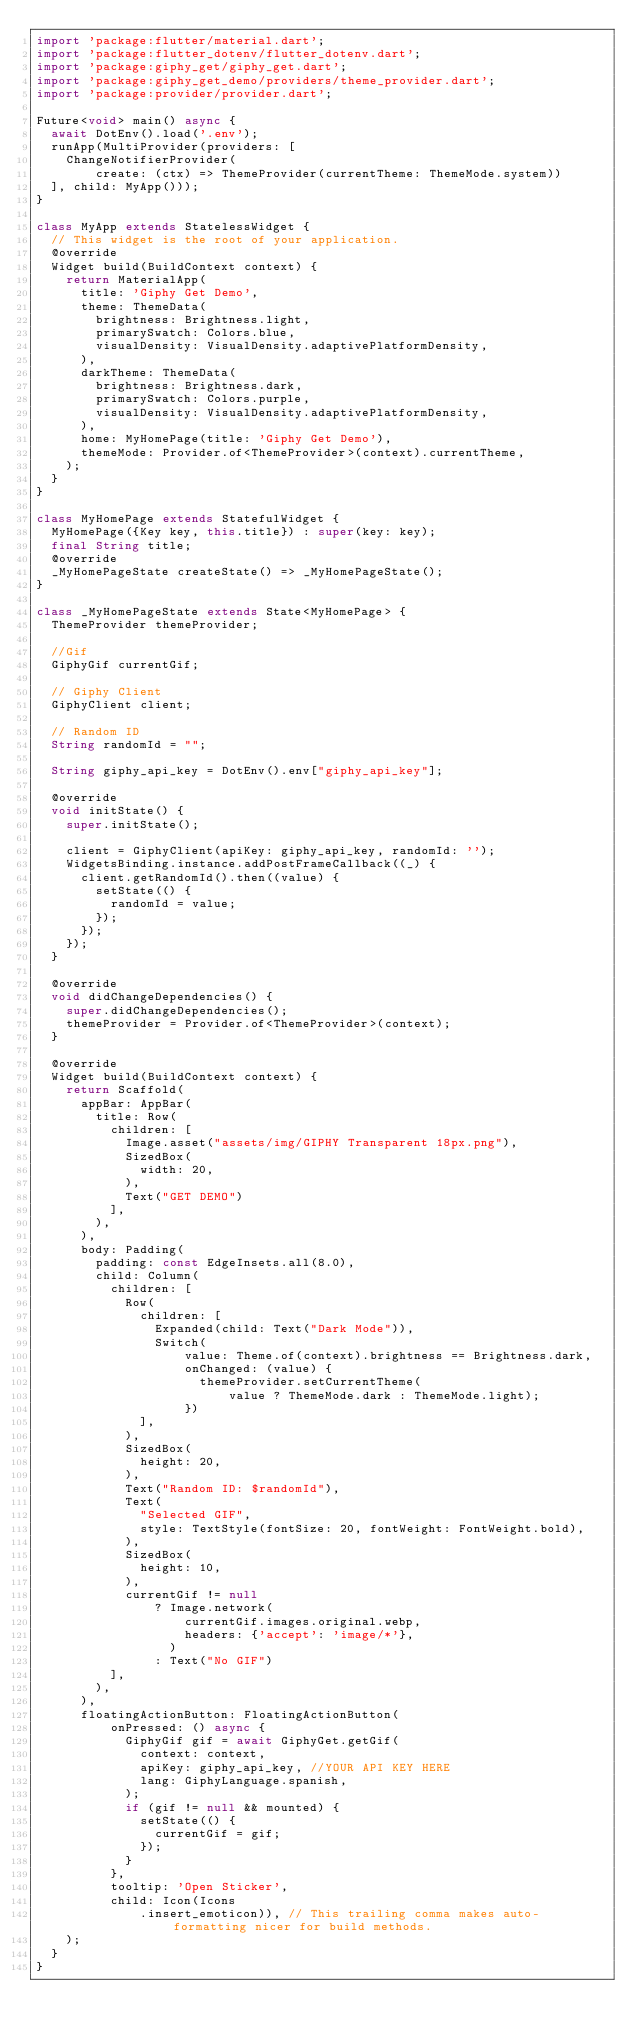<code> <loc_0><loc_0><loc_500><loc_500><_Dart_>import 'package:flutter/material.dart';
import 'package:flutter_dotenv/flutter_dotenv.dart';
import 'package:giphy_get/giphy_get.dart';
import 'package:giphy_get_demo/providers/theme_provider.dart';
import 'package:provider/provider.dart';

Future<void> main() async {
  await DotEnv().load('.env');
  runApp(MultiProvider(providers: [
    ChangeNotifierProvider(
        create: (ctx) => ThemeProvider(currentTheme: ThemeMode.system))
  ], child: MyApp()));
}

class MyApp extends StatelessWidget {
  // This widget is the root of your application.
  @override
  Widget build(BuildContext context) {
    return MaterialApp(
      title: 'Giphy Get Demo',
      theme: ThemeData(
        brightness: Brightness.light,
        primarySwatch: Colors.blue,
        visualDensity: VisualDensity.adaptivePlatformDensity,
      ),
      darkTheme: ThemeData(
        brightness: Brightness.dark,
        primarySwatch: Colors.purple,
        visualDensity: VisualDensity.adaptivePlatformDensity,
      ),
      home: MyHomePage(title: 'Giphy Get Demo'),
      themeMode: Provider.of<ThemeProvider>(context).currentTheme,
    );
  }
}

class MyHomePage extends StatefulWidget {
  MyHomePage({Key key, this.title}) : super(key: key);
  final String title;
  @override
  _MyHomePageState createState() => _MyHomePageState();
}

class _MyHomePageState extends State<MyHomePage> {
  ThemeProvider themeProvider;

  //Gif
  GiphyGif currentGif;

  // Giphy Client
  GiphyClient client;

  // Random ID
  String randomId = "";

  String giphy_api_key = DotEnv().env["giphy_api_key"];

  @override
  void initState() {
    super.initState();

    client = GiphyClient(apiKey: giphy_api_key, randomId: '');
    WidgetsBinding.instance.addPostFrameCallback((_) {
      client.getRandomId().then((value) {
        setState(() {
          randomId = value;
        });
      });
    });
  }

  @override
  void didChangeDependencies() {
    super.didChangeDependencies();
    themeProvider = Provider.of<ThemeProvider>(context);
  }

  @override
  Widget build(BuildContext context) {
    return Scaffold(
      appBar: AppBar(
        title: Row(
          children: [
            Image.asset("assets/img/GIPHY Transparent 18px.png"),
            SizedBox(
              width: 20,
            ),
            Text("GET DEMO")
          ],
        ),
      ),
      body: Padding(
        padding: const EdgeInsets.all(8.0),
        child: Column(
          children: [
            Row(
              children: [
                Expanded(child: Text("Dark Mode")),
                Switch(
                    value: Theme.of(context).brightness == Brightness.dark,
                    onChanged: (value) {
                      themeProvider.setCurrentTheme(
                          value ? ThemeMode.dark : ThemeMode.light);
                    })
              ],
            ),
            SizedBox(
              height: 20,
            ),
            Text("Random ID: $randomId"),
            Text(
              "Selected GIF",
              style: TextStyle(fontSize: 20, fontWeight: FontWeight.bold),
            ),
            SizedBox(
              height: 10,
            ),
            currentGif != null
                ? Image.network(
                    currentGif.images.original.webp,
                    headers: {'accept': 'image/*'},
                  )
                : Text("No GIF")
          ],
        ),
      ),
      floatingActionButton: FloatingActionButton(
          onPressed: () async {
            GiphyGif gif = await GiphyGet.getGif(
              context: context,
              apiKey: giphy_api_key, //YOUR API KEY HERE
              lang: GiphyLanguage.spanish,
            );
            if (gif != null && mounted) {
              setState(() {
                currentGif = gif;
              });
            }
          },
          tooltip: 'Open Sticker',
          child: Icon(Icons
              .insert_emoticon)), // This trailing comma makes auto-formatting nicer for build methods.
    );
  }
}
</code> 